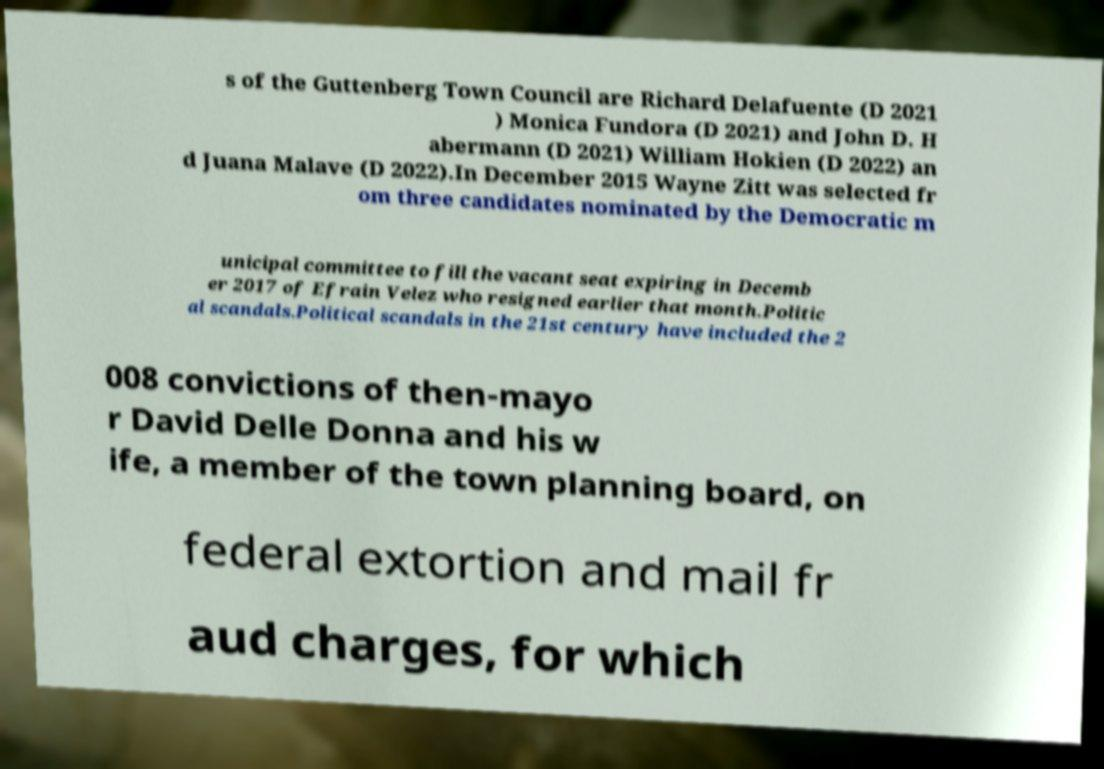Can you accurately transcribe the text from the provided image for me? s of the Guttenberg Town Council are Richard Delafuente (D 2021 ) Monica Fundora (D 2021) and John D. H abermann (D 2021) William Hokien (D 2022) an d Juana Malave (D 2022).In December 2015 Wayne Zitt was selected fr om three candidates nominated by the Democratic m unicipal committee to fill the vacant seat expiring in Decemb er 2017 of Efrain Velez who resigned earlier that month.Politic al scandals.Political scandals in the 21st century have included the 2 008 convictions of then-mayo r David Delle Donna and his w ife, a member of the town planning board, on federal extortion and mail fr aud charges, for which 